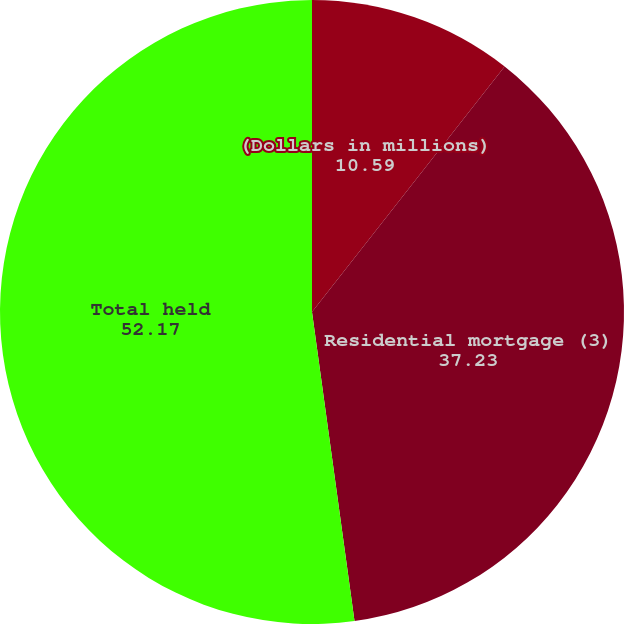Convert chart to OTSL. <chart><loc_0><loc_0><loc_500><loc_500><pie_chart><fcel>(Dollars in millions)<fcel>Residential mortgage (3)<fcel>Total held<nl><fcel>10.59%<fcel>37.23%<fcel>52.17%<nl></chart> 